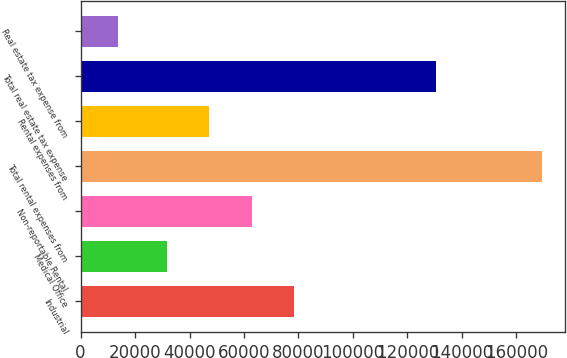Convert chart. <chart><loc_0><loc_0><loc_500><loc_500><bar_chart><fcel>Industrial<fcel>Medical Office<fcel>Non-reportable Rental<fcel>Total rental expenses from<fcel>Rental expenses from<fcel>Total real estate tax expense<fcel>Real estate tax expense from<nl><fcel>78349.1<fcel>31649<fcel>62782.4<fcel>169534<fcel>47215.7<fcel>130580<fcel>13867<nl></chart> 